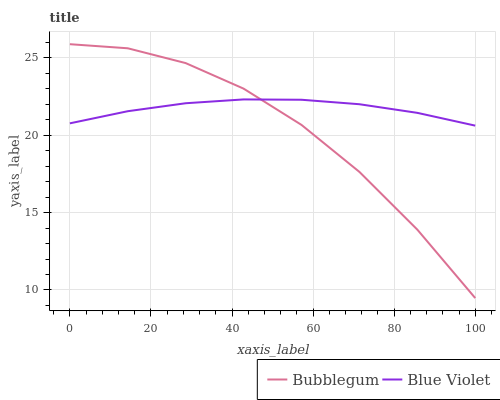Does Bubblegum have the minimum area under the curve?
Answer yes or no. Yes. Does Blue Violet have the maximum area under the curve?
Answer yes or no. Yes. Does Bubblegum have the maximum area under the curve?
Answer yes or no. No. Is Blue Violet the smoothest?
Answer yes or no. Yes. Is Bubblegum the roughest?
Answer yes or no. Yes. Is Bubblegum the smoothest?
Answer yes or no. No. Does Bubblegum have the lowest value?
Answer yes or no. Yes. Does Bubblegum have the highest value?
Answer yes or no. Yes. Does Bubblegum intersect Blue Violet?
Answer yes or no. Yes. Is Bubblegum less than Blue Violet?
Answer yes or no. No. Is Bubblegum greater than Blue Violet?
Answer yes or no. No. 